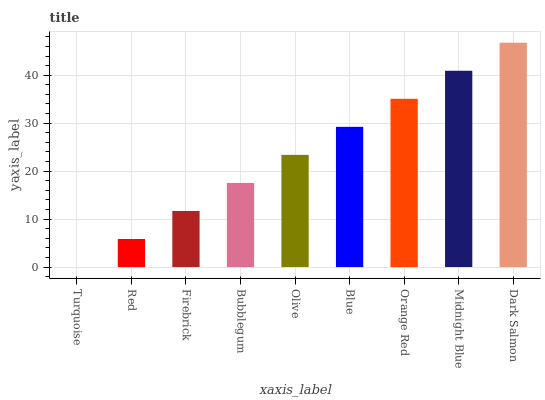Is Turquoise the minimum?
Answer yes or no. Yes. Is Dark Salmon the maximum?
Answer yes or no. Yes. Is Red the minimum?
Answer yes or no. No. Is Red the maximum?
Answer yes or no. No. Is Red greater than Turquoise?
Answer yes or no. Yes. Is Turquoise less than Red?
Answer yes or no. Yes. Is Turquoise greater than Red?
Answer yes or no. No. Is Red less than Turquoise?
Answer yes or no. No. Is Olive the high median?
Answer yes or no. Yes. Is Olive the low median?
Answer yes or no. Yes. Is Dark Salmon the high median?
Answer yes or no. No. Is Bubblegum the low median?
Answer yes or no. No. 